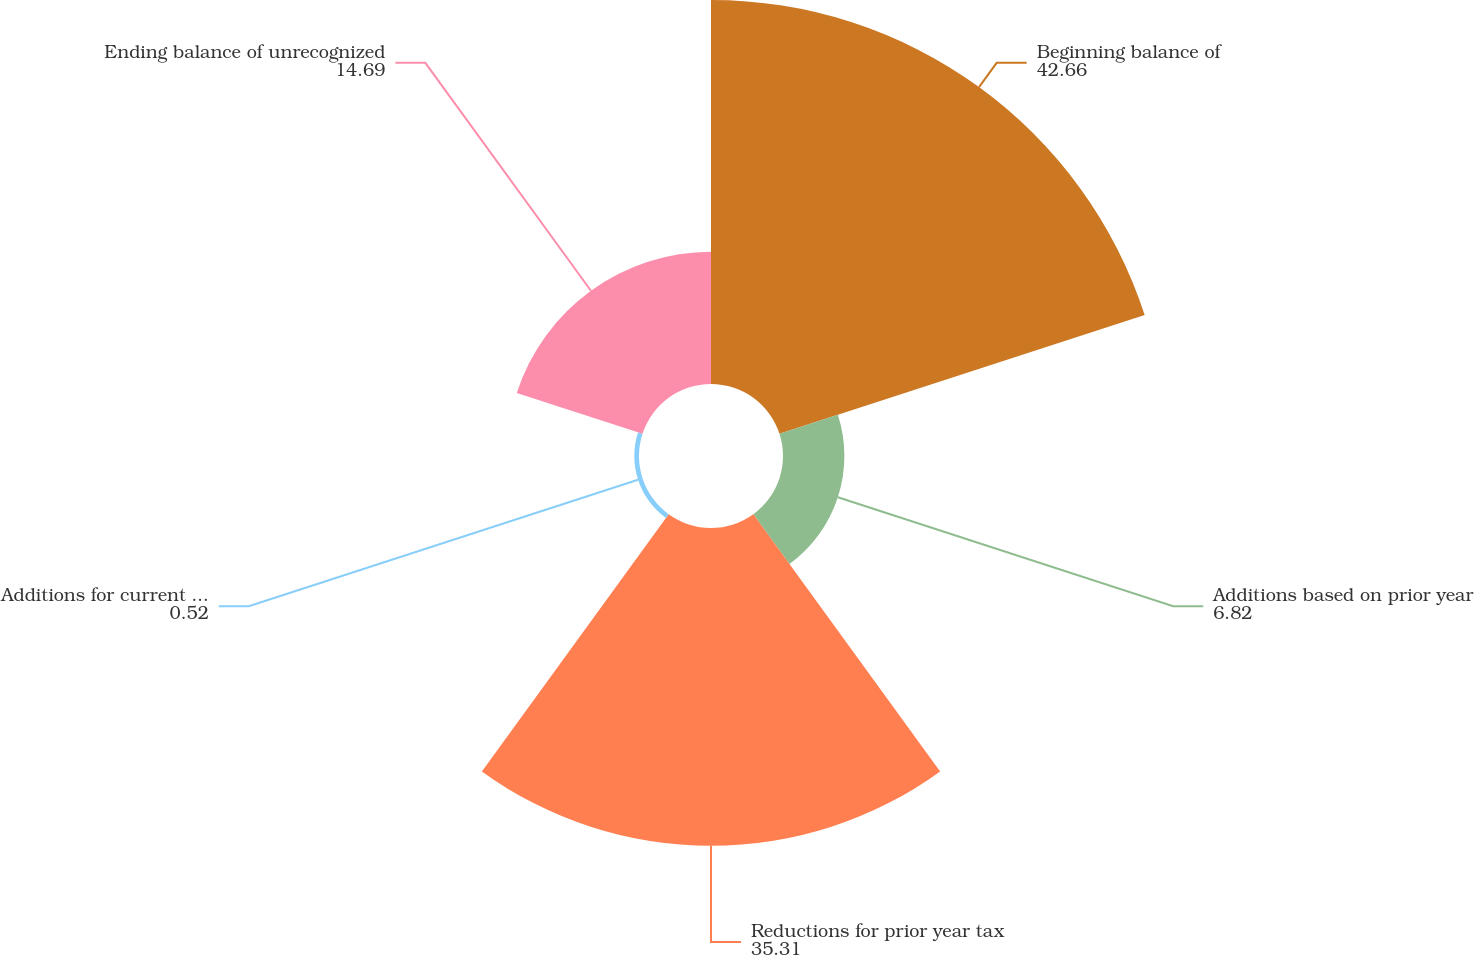Convert chart. <chart><loc_0><loc_0><loc_500><loc_500><pie_chart><fcel>Beginning balance of<fcel>Additions based on prior year<fcel>Reductions for prior year tax<fcel>Additions for current year tax<fcel>Ending balance of unrecognized<nl><fcel>42.66%<fcel>6.82%<fcel>35.31%<fcel>0.52%<fcel>14.69%<nl></chart> 